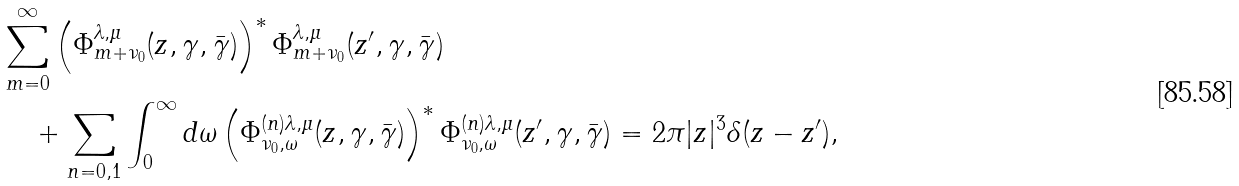<formula> <loc_0><loc_0><loc_500><loc_500>& \sum _ { m = 0 } ^ { \infty } \left ( \Phi ^ { \lambda , \mu } _ { m + \nu _ { 0 } } ( z , \gamma , \bar { \gamma } ) \right ) ^ { * } \Phi ^ { \lambda , \mu } _ { m + \nu _ { 0 } } ( z ^ { \prime } , \gamma , \bar { \gamma } ) \\ & \quad + \sum _ { n = 0 , 1 } \int _ { 0 } ^ { \infty } d \omega \left ( \Phi ^ { ( n ) \lambda , \mu } _ { \nu _ { 0 } , \omega } ( z , \gamma , \bar { \gamma } ) \right ) ^ { * } \Phi ^ { ( n ) \lambda , \mu } _ { \nu _ { 0 } , \omega } ( z ^ { \prime } , \gamma , \bar { \gamma } ) = 2 \pi | z | ^ { 3 } \delta ( z - z ^ { \prime } ) ,</formula> 